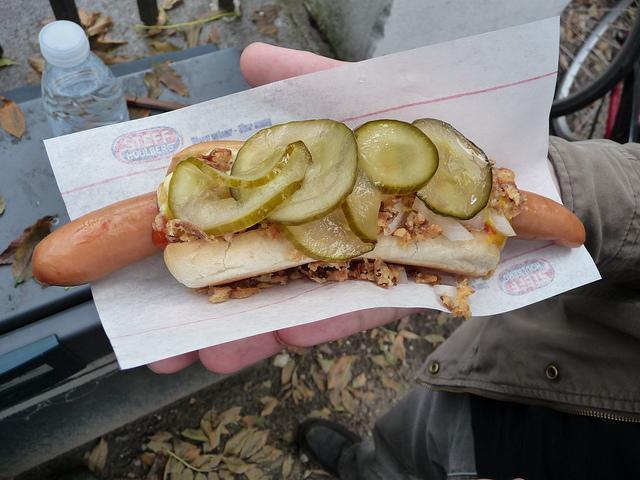Is the statement "The hot dog is touching the person." accurate regarding the image?
Answer yes or no. No. 